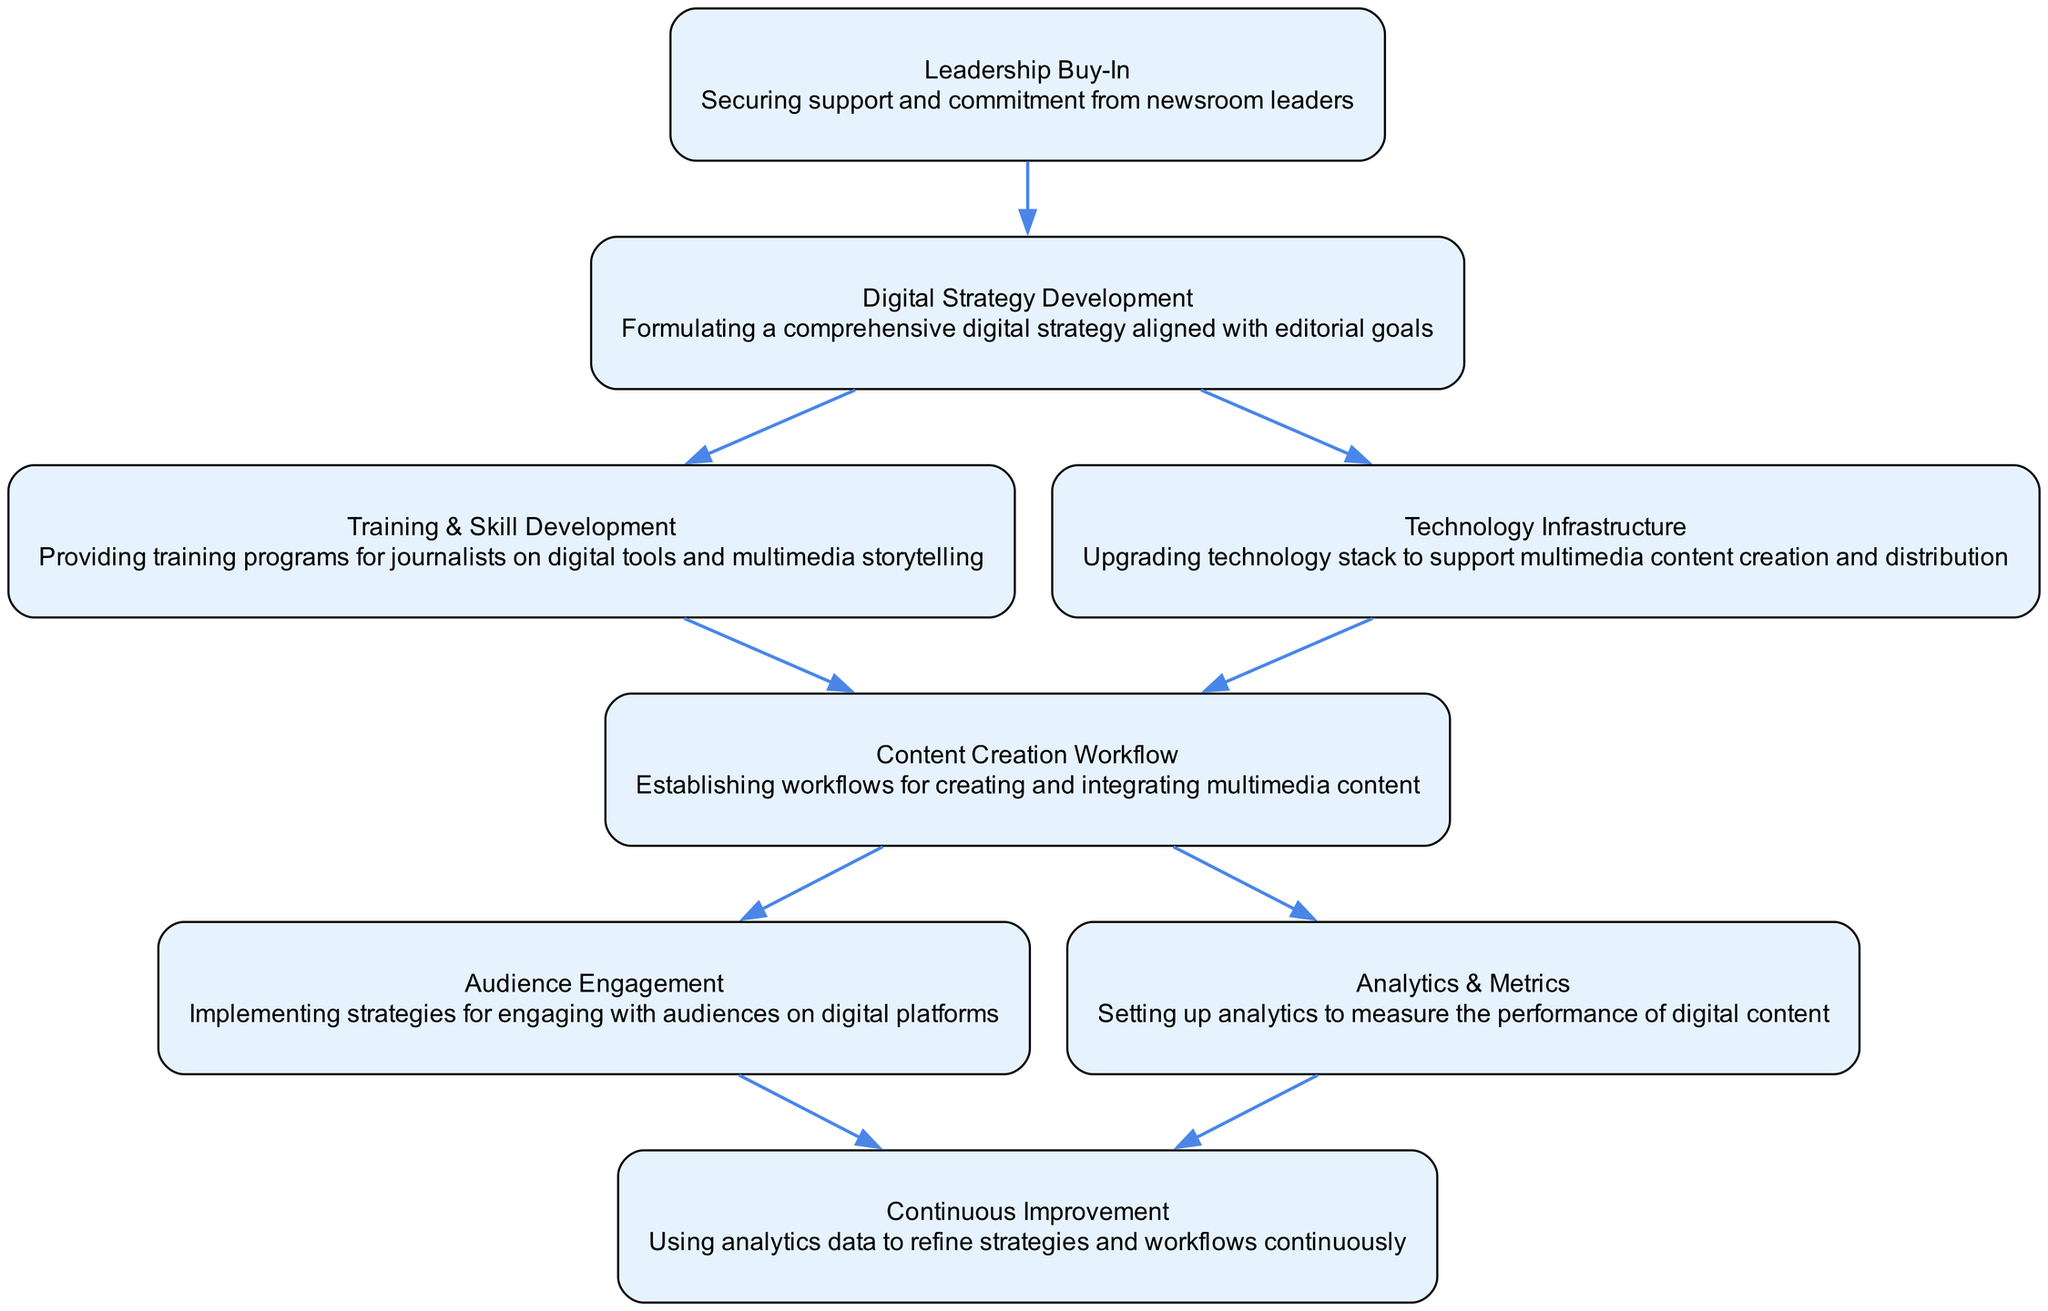What is the first step in the transition workflow? The first step in the transition workflow is "Leadership Buy-In," which is critical for securing support and commitment from newsroom leaders to initiate the process of transition.
Answer: Leadership Buy-In How many connections does "Digital Strategy Development" have? "Digital Strategy Development" has two connections, indicating it branches out to two subsequent steps in the workflow: "Training & Skill Development" and "Technology Infrastructure."
Answer: 2 What is the last step in the transition workflow? The last step in the transition workflow is "Continuous Improvement," which emphasizes the need for ongoing refinement of strategies and workflows based on analytics data.
Answer: Continuous Improvement Which blocks lead to "Content Creation Workflow"? The blocks that lead to "Content Creation Workflow" are "Training & Skill Development" and "Technology Infrastructure," both of which are essential to establishing workflows for creating multimedia content.
Answer: Training & Skill Development, Technology Infrastructure What block is responsible for audience interaction? The block responsible for audience interaction is "Audience Engagement," which focuses on implementing strategies for engaging with audiences on digital platforms to enhance interaction and participation.
Answer: Audience Engagement How does "Analytics & Metrics" contribute to the workflow? "Analytics & Metrics" contributes to the workflow by setting up analytics to measure the performance of digital content, which allows for data-driven decision making and improvements in content strategy.
Answer: Setting up analytics Which steps must be completed before "Continuous Improvement" can be initiated? Before "Continuous Improvement" can be initiated, the steps "Audience Engagement" and "Analytics & Metrics" must be completed, as they provide the necessary data and strategies for improvement.
Answer: Audience Engagement, Analytics & Metrics What is the purpose of the "Technology Infrastructure" block? The purpose of the "Technology Infrastructure" block is to upgrade the technology stack to support multimedia content creation and distribution, ensuring that the newsroom has the necessary tools for digital transition.
Answer: Upgrade technology stack How many total blocks are present in the diagram? There are a total of eight blocks present in the diagram, delineating the various stages of transitioning from a traditional to a digital newsroom.
Answer: 8 